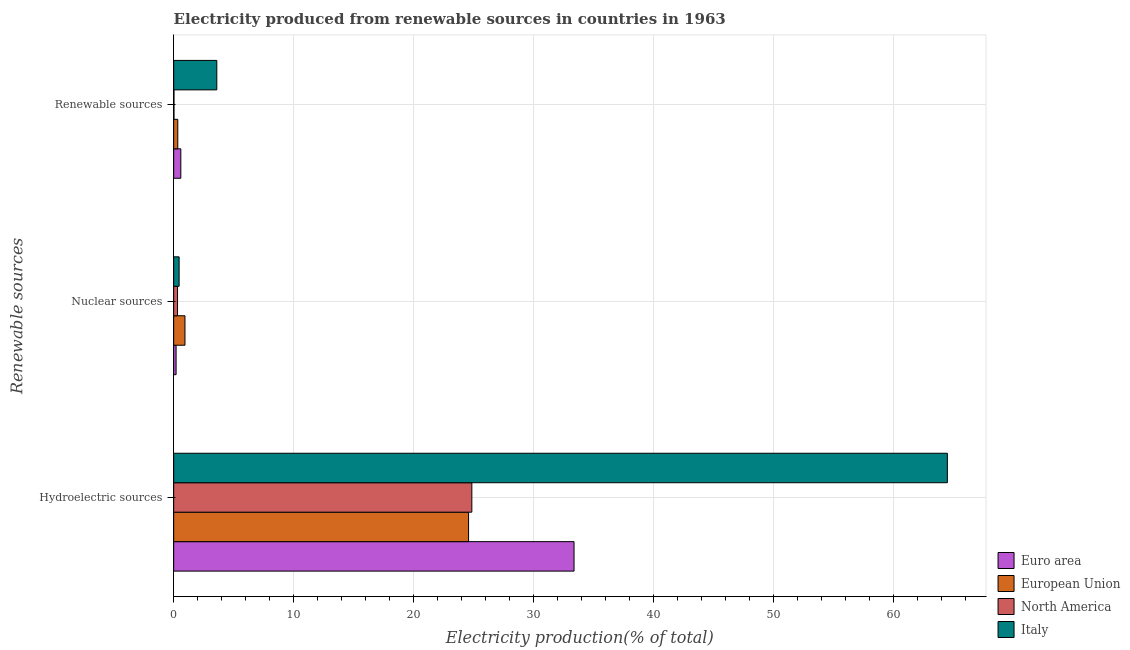How many different coloured bars are there?
Keep it short and to the point. 4. How many groups of bars are there?
Your response must be concise. 3. Are the number of bars per tick equal to the number of legend labels?
Keep it short and to the point. Yes. What is the label of the 1st group of bars from the top?
Provide a succinct answer. Renewable sources. What is the percentage of electricity produced by renewable sources in North America?
Provide a short and direct response. 0.03. Across all countries, what is the maximum percentage of electricity produced by hydroelectric sources?
Offer a terse response. 64.47. Across all countries, what is the minimum percentage of electricity produced by hydroelectric sources?
Give a very brief answer. 24.57. In which country was the percentage of electricity produced by nuclear sources minimum?
Give a very brief answer. Euro area. What is the total percentage of electricity produced by hydroelectric sources in the graph?
Provide a short and direct response. 147.25. What is the difference between the percentage of electricity produced by renewable sources in North America and that in European Union?
Make the answer very short. -0.32. What is the difference between the percentage of electricity produced by nuclear sources in North America and the percentage of electricity produced by hydroelectric sources in Italy?
Keep it short and to the point. -64.15. What is the average percentage of electricity produced by renewable sources per country?
Offer a very short reply. 1.14. What is the difference between the percentage of electricity produced by hydroelectric sources and percentage of electricity produced by nuclear sources in European Union?
Your answer should be very brief. 23.63. In how many countries, is the percentage of electricity produced by hydroelectric sources greater than 30 %?
Provide a succinct answer. 2. What is the ratio of the percentage of electricity produced by renewable sources in European Union to that in Italy?
Keep it short and to the point. 0.1. What is the difference between the highest and the second highest percentage of electricity produced by hydroelectric sources?
Offer a very short reply. 31.11. What is the difference between the highest and the lowest percentage of electricity produced by renewable sources?
Give a very brief answer. 3.57. In how many countries, is the percentage of electricity produced by nuclear sources greater than the average percentage of electricity produced by nuclear sources taken over all countries?
Offer a very short reply. 1. Is the sum of the percentage of electricity produced by hydroelectric sources in North America and Euro area greater than the maximum percentage of electricity produced by nuclear sources across all countries?
Your answer should be very brief. Yes. What does the 3rd bar from the top in Hydroelectric sources represents?
Your answer should be very brief. European Union. Is it the case that in every country, the sum of the percentage of electricity produced by hydroelectric sources and percentage of electricity produced by nuclear sources is greater than the percentage of electricity produced by renewable sources?
Offer a terse response. Yes. How many bars are there?
Your response must be concise. 12. Are the values on the major ticks of X-axis written in scientific E-notation?
Provide a short and direct response. No. Does the graph contain any zero values?
Keep it short and to the point. No. Does the graph contain grids?
Make the answer very short. Yes. Where does the legend appear in the graph?
Offer a very short reply. Bottom right. What is the title of the graph?
Provide a succinct answer. Electricity produced from renewable sources in countries in 1963. What is the label or title of the X-axis?
Make the answer very short. Electricity production(% of total). What is the label or title of the Y-axis?
Offer a very short reply. Renewable sources. What is the Electricity production(% of total) in Euro area in Hydroelectric sources?
Provide a succinct answer. 33.36. What is the Electricity production(% of total) in European Union in Hydroelectric sources?
Your answer should be compact. 24.57. What is the Electricity production(% of total) of North America in Hydroelectric sources?
Keep it short and to the point. 24.84. What is the Electricity production(% of total) of Italy in Hydroelectric sources?
Offer a very short reply. 64.47. What is the Electricity production(% of total) of Euro area in Nuclear sources?
Offer a very short reply. 0.2. What is the Electricity production(% of total) of European Union in Nuclear sources?
Your answer should be compact. 0.94. What is the Electricity production(% of total) of North America in Nuclear sources?
Your response must be concise. 0.32. What is the Electricity production(% of total) in Italy in Nuclear sources?
Offer a terse response. 0.45. What is the Electricity production(% of total) in Euro area in Renewable sources?
Keep it short and to the point. 0.59. What is the Electricity production(% of total) of European Union in Renewable sources?
Provide a short and direct response. 0.34. What is the Electricity production(% of total) in North America in Renewable sources?
Ensure brevity in your answer.  0.03. What is the Electricity production(% of total) in Italy in Renewable sources?
Your answer should be compact. 3.59. Across all Renewable sources, what is the maximum Electricity production(% of total) in Euro area?
Ensure brevity in your answer.  33.36. Across all Renewable sources, what is the maximum Electricity production(% of total) of European Union?
Keep it short and to the point. 24.57. Across all Renewable sources, what is the maximum Electricity production(% of total) in North America?
Your response must be concise. 24.84. Across all Renewable sources, what is the maximum Electricity production(% of total) in Italy?
Your answer should be compact. 64.47. Across all Renewable sources, what is the minimum Electricity production(% of total) of Euro area?
Provide a short and direct response. 0.2. Across all Renewable sources, what is the minimum Electricity production(% of total) of European Union?
Give a very brief answer. 0.34. Across all Renewable sources, what is the minimum Electricity production(% of total) in North America?
Your answer should be compact. 0.03. Across all Renewable sources, what is the minimum Electricity production(% of total) of Italy?
Your response must be concise. 0.45. What is the total Electricity production(% of total) in Euro area in the graph?
Give a very brief answer. 34.16. What is the total Electricity production(% of total) in European Union in the graph?
Give a very brief answer. 25.86. What is the total Electricity production(% of total) of North America in the graph?
Keep it short and to the point. 25.19. What is the total Electricity production(% of total) in Italy in the graph?
Your answer should be very brief. 68.52. What is the difference between the Electricity production(% of total) in Euro area in Hydroelectric sources and that in Nuclear sources?
Offer a very short reply. 33.16. What is the difference between the Electricity production(% of total) in European Union in Hydroelectric sources and that in Nuclear sources?
Keep it short and to the point. 23.63. What is the difference between the Electricity production(% of total) in North America in Hydroelectric sources and that in Nuclear sources?
Offer a terse response. 24.52. What is the difference between the Electricity production(% of total) of Italy in Hydroelectric sources and that in Nuclear sources?
Your answer should be compact. 64.01. What is the difference between the Electricity production(% of total) in Euro area in Hydroelectric sources and that in Renewable sources?
Provide a succinct answer. 32.77. What is the difference between the Electricity production(% of total) of European Union in Hydroelectric sources and that in Renewable sources?
Ensure brevity in your answer.  24.23. What is the difference between the Electricity production(% of total) in North America in Hydroelectric sources and that in Renewable sources?
Provide a succinct answer. 24.82. What is the difference between the Electricity production(% of total) in Italy in Hydroelectric sources and that in Renewable sources?
Keep it short and to the point. 60.87. What is the difference between the Electricity production(% of total) of Euro area in Nuclear sources and that in Renewable sources?
Your answer should be compact. -0.39. What is the difference between the Electricity production(% of total) of European Union in Nuclear sources and that in Renewable sources?
Your answer should be compact. 0.6. What is the difference between the Electricity production(% of total) of North America in Nuclear sources and that in Renewable sources?
Ensure brevity in your answer.  0.3. What is the difference between the Electricity production(% of total) in Italy in Nuclear sources and that in Renewable sources?
Ensure brevity in your answer.  -3.14. What is the difference between the Electricity production(% of total) of Euro area in Hydroelectric sources and the Electricity production(% of total) of European Union in Nuclear sources?
Provide a succinct answer. 32.42. What is the difference between the Electricity production(% of total) of Euro area in Hydroelectric sources and the Electricity production(% of total) of North America in Nuclear sources?
Provide a succinct answer. 33.04. What is the difference between the Electricity production(% of total) of Euro area in Hydroelectric sources and the Electricity production(% of total) of Italy in Nuclear sources?
Keep it short and to the point. 32.91. What is the difference between the Electricity production(% of total) of European Union in Hydroelectric sources and the Electricity production(% of total) of North America in Nuclear sources?
Give a very brief answer. 24.25. What is the difference between the Electricity production(% of total) of European Union in Hydroelectric sources and the Electricity production(% of total) of Italy in Nuclear sources?
Your answer should be compact. 24.12. What is the difference between the Electricity production(% of total) of North America in Hydroelectric sources and the Electricity production(% of total) of Italy in Nuclear sources?
Ensure brevity in your answer.  24.39. What is the difference between the Electricity production(% of total) of Euro area in Hydroelectric sources and the Electricity production(% of total) of European Union in Renewable sources?
Your response must be concise. 33.02. What is the difference between the Electricity production(% of total) of Euro area in Hydroelectric sources and the Electricity production(% of total) of North America in Renewable sources?
Your answer should be compact. 33.34. What is the difference between the Electricity production(% of total) in Euro area in Hydroelectric sources and the Electricity production(% of total) in Italy in Renewable sources?
Give a very brief answer. 29.77. What is the difference between the Electricity production(% of total) in European Union in Hydroelectric sources and the Electricity production(% of total) in North America in Renewable sources?
Give a very brief answer. 24.55. What is the difference between the Electricity production(% of total) of European Union in Hydroelectric sources and the Electricity production(% of total) of Italy in Renewable sources?
Provide a succinct answer. 20.98. What is the difference between the Electricity production(% of total) of North America in Hydroelectric sources and the Electricity production(% of total) of Italy in Renewable sources?
Make the answer very short. 21.25. What is the difference between the Electricity production(% of total) of Euro area in Nuclear sources and the Electricity production(% of total) of European Union in Renewable sources?
Make the answer very short. -0.14. What is the difference between the Electricity production(% of total) of Euro area in Nuclear sources and the Electricity production(% of total) of North America in Renewable sources?
Offer a terse response. 0.18. What is the difference between the Electricity production(% of total) of Euro area in Nuclear sources and the Electricity production(% of total) of Italy in Renewable sources?
Your answer should be very brief. -3.39. What is the difference between the Electricity production(% of total) in European Union in Nuclear sources and the Electricity production(% of total) in North America in Renewable sources?
Your answer should be compact. 0.92. What is the difference between the Electricity production(% of total) in European Union in Nuclear sources and the Electricity production(% of total) in Italy in Renewable sources?
Keep it short and to the point. -2.65. What is the difference between the Electricity production(% of total) of North America in Nuclear sources and the Electricity production(% of total) of Italy in Renewable sources?
Provide a short and direct response. -3.27. What is the average Electricity production(% of total) in Euro area per Renewable sources?
Keep it short and to the point. 11.39. What is the average Electricity production(% of total) of European Union per Renewable sources?
Your response must be concise. 8.62. What is the average Electricity production(% of total) of North America per Renewable sources?
Provide a short and direct response. 8.4. What is the average Electricity production(% of total) of Italy per Renewable sources?
Offer a terse response. 22.84. What is the difference between the Electricity production(% of total) in Euro area and Electricity production(% of total) in European Union in Hydroelectric sources?
Offer a terse response. 8.79. What is the difference between the Electricity production(% of total) in Euro area and Electricity production(% of total) in North America in Hydroelectric sources?
Your response must be concise. 8.52. What is the difference between the Electricity production(% of total) in Euro area and Electricity production(% of total) in Italy in Hydroelectric sources?
Your response must be concise. -31.11. What is the difference between the Electricity production(% of total) in European Union and Electricity production(% of total) in North America in Hydroelectric sources?
Offer a very short reply. -0.27. What is the difference between the Electricity production(% of total) in European Union and Electricity production(% of total) in Italy in Hydroelectric sources?
Provide a short and direct response. -39.9. What is the difference between the Electricity production(% of total) of North America and Electricity production(% of total) of Italy in Hydroelectric sources?
Your response must be concise. -39.62. What is the difference between the Electricity production(% of total) in Euro area and Electricity production(% of total) in European Union in Nuclear sources?
Your answer should be compact. -0.74. What is the difference between the Electricity production(% of total) in Euro area and Electricity production(% of total) in North America in Nuclear sources?
Make the answer very short. -0.12. What is the difference between the Electricity production(% of total) of Euro area and Electricity production(% of total) of Italy in Nuclear sources?
Offer a very short reply. -0.25. What is the difference between the Electricity production(% of total) of European Union and Electricity production(% of total) of North America in Nuclear sources?
Your answer should be compact. 0.62. What is the difference between the Electricity production(% of total) in European Union and Electricity production(% of total) in Italy in Nuclear sources?
Provide a short and direct response. 0.49. What is the difference between the Electricity production(% of total) in North America and Electricity production(% of total) in Italy in Nuclear sources?
Keep it short and to the point. -0.13. What is the difference between the Electricity production(% of total) of Euro area and Electricity production(% of total) of European Union in Renewable sources?
Make the answer very short. 0.25. What is the difference between the Electricity production(% of total) in Euro area and Electricity production(% of total) in North America in Renewable sources?
Ensure brevity in your answer.  0.57. What is the difference between the Electricity production(% of total) of Euro area and Electricity production(% of total) of Italy in Renewable sources?
Your answer should be compact. -3. What is the difference between the Electricity production(% of total) of European Union and Electricity production(% of total) of North America in Renewable sources?
Offer a terse response. 0.32. What is the difference between the Electricity production(% of total) of European Union and Electricity production(% of total) of Italy in Renewable sources?
Offer a terse response. -3.25. What is the difference between the Electricity production(% of total) of North America and Electricity production(% of total) of Italy in Renewable sources?
Give a very brief answer. -3.57. What is the ratio of the Electricity production(% of total) in Euro area in Hydroelectric sources to that in Nuclear sources?
Your answer should be very brief. 165.41. What is the ratio of the Electricity production(% of total) in European Union in Hydroelectric sources to that in Nuclear sources?
Make the answer very short. 26.1. What is the ratio of the Electricity production(% of total) of North America in Hydroelectric sources to that in Nuclear sources?
Offer a terse response. 77.18. What is the ratio of the Electricity production(% of total) in Italy in Hydroelectric sources to that in Nuclear sources?
Provide a succinct answer. 141.76. What is the ratio of the Electricity production(% of total) in Euro area in Hydroelectric sources to that in Renewable sources?
Make the answer very short. 56.14. What is the ratio of the Electricity production(% of total) of European Union in Hydroelectric sources to that in Renewable sources?
Make the answer very short. 71.68. What is the ratio of the Electricity production(% of total) in North America in Hydroelectric sources to that in Renewable sources?
Offer a very short reply. 952.6. What is the ratio of the Electricity production(% of total) of Italy in Hydroelectric sources to that in Renewable sources?
Ensure brevity in your answer.  17.94. What is the ratio of the Electricity production(% of total) in Euro area in Nuclear sources to that in Renewable sources?
Your answer should be very brief. 0.34. What is the ratio of the Electricity production(% of total) in European Union in Nuclear sources to that in Renewable sources?
Provide a short and direct response. 2.75. What is the ratio of the Electricity production(% of total) in North America in Nuclear sources to that in Renewable sources?
Provide a short and direct response. 12.34. What is the ratio of the Electricity production(% of total) in Italy in Nuclear sources to that in Renewable sources?
Keep it short and to the point. 0.13. What is the difference between the highest and the second highest Electricity production(% of total) of Euro area?
Offer a very short reply. 32.77. What is the difference between the highest and the second highest Electricity production(% of total) in European Union?
Give a very brief answer. 23.63. What is the difference between the highest and the second highest Electricity production(% of total) in North America?
Provide a short and direct response. 24.52. What is the difference between the highest and the second highest Electricity production(% of total) of Italy?
Offer a very short reply. 60.87. What is the difference between the highest and the lowest Electricity production(% of total) of Euro area?
Your response must be concise. 33.16. What is the difference between the highest and the lowest Electricity production(% of total) in European Union?
Your response must be concise. 24.23. What is the difference between the highest and the lowest Electricity production(% of total) of North America?
Keep it short and to the point. 24.82. What is the difference between the highest and the lowest Electricity production(% of total) in Italy?
Keep it short and to the point. 64.01. 